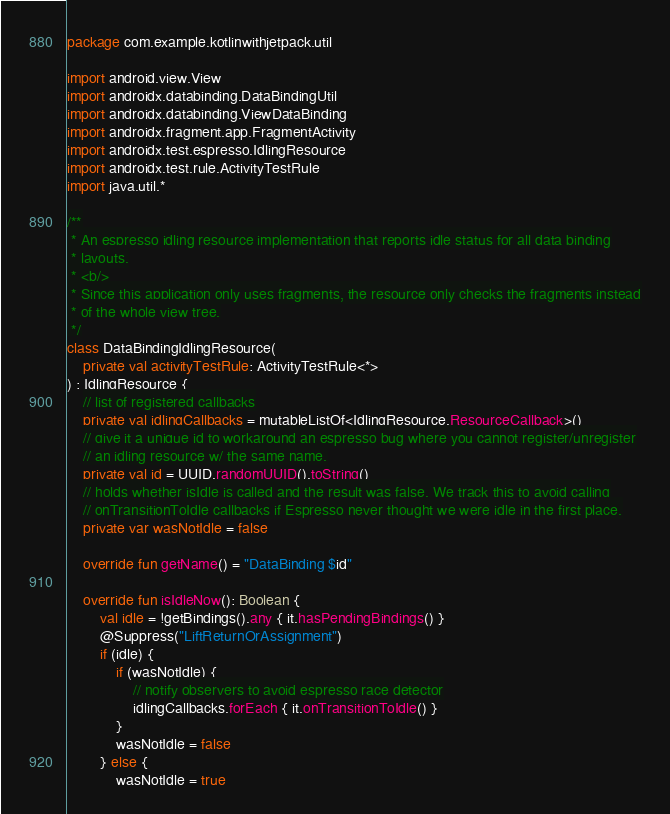<code> <loc_0><loc_0><loc_500><loc_500><_Kotlin_>package com.example.kotlinwithjetpack.util

import android.view.View
import androidx.databinding.DataBindingUtil
import androidx.databinding.ViewDataBinding
import androidx.fragment.app.FragmentActivity
import androidx.test.espresso.IdlingResource
import androidx.test.rule.ActivityTestRule
import java.util.*

/**
 * An espresso idling resource implementation that reports idle status for all data binding
 * layouts.
 * <b/>
 * Since this application only uses fragments, the resource only checks the fragments instead
 * of the whole view tree.
 */
class DataBindingIdlingResource(
    private val activityTestRule: ActivityTestRule<*>
) : IdlingResource {
    // list of registered callbacks
    private val idlingCallbacks = mutableListOf<IdlingResource.ResourceCallback>()
    // give it a unique id to workaround an espresso bug where you cannot register/unregister
    // an idling resource w/ the same name.
    private val id = UUID.randomUUID().toString()
    // holds whether isIdle is called and the result was false. We track this to avoid calling
    // onTransitionToIdle callbacks if Espresso never thought we were idle in the first place.
    private var wasNotIdle = false

    override fun getName() = "DataBinding $id"

    override fun isIdleNow(): Boolean {
        val idle = !getBindings().any { it.hasPendingBindings() }
        @Suppress("LiftReturnOrAssignment")
        if (idle) {
            if (wasNotIdle) {
                // notify observers to avoid espresso race detector
                idlingCallbacks.forEach { it.onTransitionToIdle() }
            }
            wasNotIdle = false
        } else {
            wasNotIdle = true</code> 